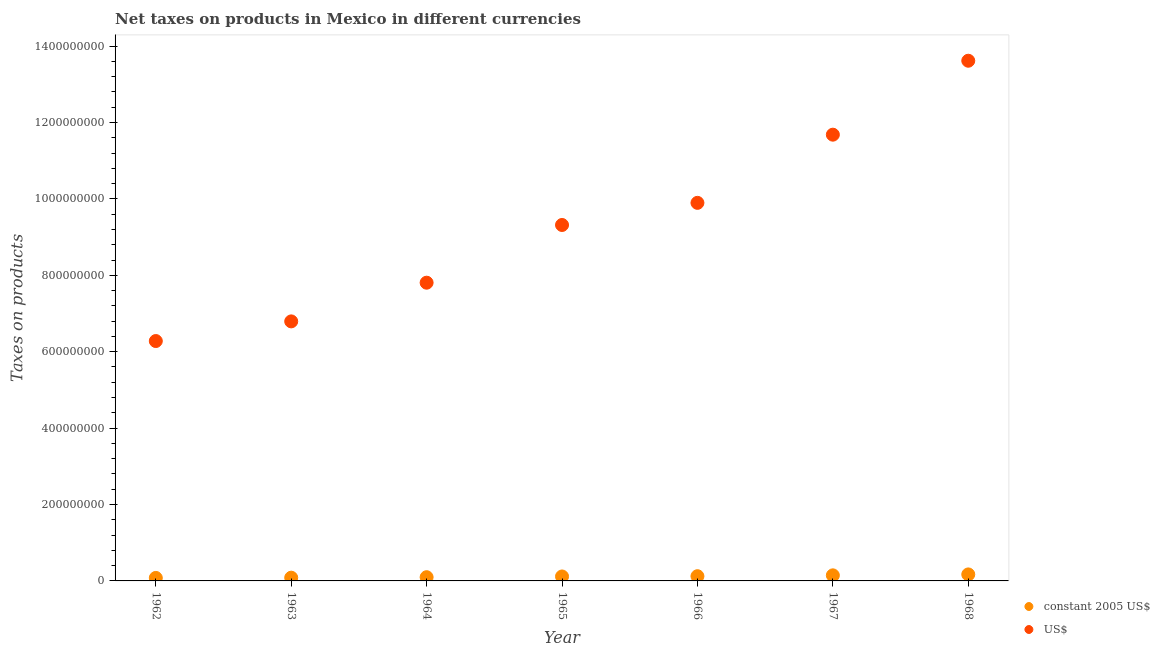Is the number of dotlines equal to the number of legend labels?
Make the answer very short. Yes. What is the net taxes in constant 2005 us$ in 1968?
Your answer should be compact. 1.70e+07. Across all years, what is the maximum net taxes in us$?
Offer a terse response. 1.36e+09. Across all years, what is the minimum net taxes in constant 2005 us$?
Your answer should be compact. 7.85e+06. In which year was the net taxes in constant 2005 us$ maximum?
Make the answer very short. 1968. In which year was the net taxes in us$ minimum?
Your response must be concise. 1962. What is the total net taxes in us$ in the graph?
Your answer should be compact. 6.54e+09. What is the difference between the net taxes in us$ in 1963 and that in 1965?
Ensure brevity in your answer.  -2.52e+08. What is the difference between the net taxes in constant 2005 us$ in 1963 and the net taxes in us$ in 1965?
Your answer should be compact. -9.23e+08. What is the average net taxes in constant 2005 us$ per year?
Provide a succinct answer. 1.17e+07. In the year 1964, what is the difference between the net taxes in constant 2005 us$ and net taxes in us$?
Give a very brief answer. -7.71e+08. In how many years, is the net taxes in constant 2005 us$ greater than 560000000 units?
Offer a very short reply. 0. What is the ratio of the net taxes in constant 2005 us$ in 1963 to that in 1964?
Your answer should be very brief. 0.87. Is the difference between the net taxes in us$ in 1966 and 1968 greater than the difference between the net taxes in constant 2005 us$ in 1966 and 1968?
Your answer should be very brief. No. What is the difference between the highest and the second highest net taxes in us$?
Offer a terse response. 1.94e+08. What is the difference between the highest and the lowest net taxes in constant 2005 us$?
Provide a short and direct response. 9.17e+06. Is the net taxes in us$ strictly less than the net taxes in constant 2005 us$ over the years?
Keep it short and to the point. No. What is the difference between two consecutive major ticks on the Y-axis?
Your answer should be very brief. 2.00e+08. Are the values on the major ticks of Y-axis written in scientific E-notation?
Ensure brevity in your answer.  No. Does the graph contain any zero values?
Your response must be concise. No. Does the graph contain grids?
Provide a short and direct response. No. How many legend labels are there?
Your response must be concise. 2. How are the legend labels stacked?
Your answer should be very brief. Vertical. What is the title of the graph?
Provide a succinct answer. Net taxes on products in Mexico in different currencies. What is the label or title of the X-axis?
Your answer should be very brief. Year. What is the label or title of the Y-axis?
Your response must be concise. Taxes on products. What is the Taxes on products in constant 2005 US$ in 1962?
Your answer should be very brief. 7.85e+06. What is the Taxes on products in US$ in 1962?
Give a very brief answer. 6.28e+08. What is the Taxes on products in constant 2005 US$ in 1963?
Provide a succinct answer. 8.49e+06. What is the Taxes on products of US$ in 1963?
Offer a terse response. 6.79e+08. What is the Taxes on products of constant 2005 US$ in 1964?
Offer a terse response. 9.76e+06. What is the Taxes on products in US$ in 1964?
Offer a terse response. 7.81e+08. What is the Taxes on products of constant 2005 US$ in 1965?
Keep it short and to the point. 1.16e+07. What is the Taxes on products in US$ in 1965?
Ensure brevity in your answer.  9.32e+08. What is the Taxes on products of constant 2005 US$ in 1966?
Make the answer very short. 1.24e+07. What is the Taxes on products in US$ in 1966?
Provide a short and direct response. 9.90e+08. What is the Taxes on products of constant 2005 US$ in 1967?
Your answer should be compact. 1.46e+07. What is the Taxes on products in US$ in 1967?
Keep it short and to the point. 1.17e+09. What is the Taxes on products of constant 2005 US$ in 1968?
Make the answer very short. 1.70e+07. What is the Taxes on products in US$ in 1968?
Your response must be concise. 1.36e+09. Across all years, what is the maximum Taxes on products in constant 2005 US$?
Provide a succinct answer. 1.70e+07. Across all years, what is the maximum Taxes on products in US$?
Give a very brief answer. 1.36e+09. Across all years, what is the minimum Taxes on products in constant 2005 US$?
Offer a very short reply. 7.85e+06. Across all years, what is the minimum Taxes on products of US$?
Your response must be concise. 6.28e+08. What is the total Taxes on products of constant 2005 US$ in the graph?
Make the answer very short. 8.17e+07. What is the total Taxes on products in US$ in the graph?
Your answer should be very brief. 6.54e+09. What is the difference between the Taxes on products in constant 2005 US$ in 1962 and that in 1963?
Provide a succinct answer. -6.43e+05. What is the difference between the Taxes on products in US$ in 1962 and that in 1963?
Provide a succinct answer. -5.14e+07. What is the difference between the Taxes on products in constant 2005 US$ in 1962 and that in 1964?
Your answer should be very brief. -1.91e+06. What is the difference between the Taxes on products in US$ in 1962 and that in 1964?
Your answer should be very brief. -1.53e+08. What is the difference between the Taxes on products in constant 2005 US$ in 1962 and that in 1965?
Give a very brief answer. -3.80e+06. What is the difference between the Taxes on products in US$ in 1962 and that in 1965?
Offer a very short reply. -3.04e+08. What is the difference between the Taxes on products in constant 2005 US$ in 1962 and that in 1966?
Your answer should be very brief. -4.52e+06. What is the difference between the Taxes on products of US$ in 1962 and that in 1966?
Offer a very short reply. -3.62e+08. What is the difference between the Taxes on products in constant 2005 US$ in 1962 and that in 1967?
Offer a terse response. -6.75e+06. What is the difference between the Taxes on products of US$ in 1962 and that in 1967?
Ensure brevity in your answer.  -5.40e+08. What is the difference between the Taxes on products of constant 2005 US$ in 1962 and that in 1968?
Give a very brief answer. -9.17e+06. What is the difference between the Taxes on products of US$ in 1962 and that in 1968?
Provide a short and direct response. -7.34e+08. What is the difference between the Taxes on products of constant 2005 US$ in 1963 and that in 1964?
Give a very brief answer. -1.27e+06. What is the difference between the Taxes on products of US$ in 1963 and that in 1964?
Keep it short and to the point. -1.01e+08. What is the difference between the Taxes on products in constant 2005 US$ in 1963 and that in 1965?
Make the answer very short. -3.15e+06. What is the difference between the Taxes on products of US$ in 1963 and that in 1965?
Provide a short and direct response. -2.52e+08. What is the difference between the Taxes on products in constant 2005 US$ in 1963 and that in 1966?
Your answer should be compact. -3.88e+06. What is the difference between the Taxes on products in US$ in 1963 and that in 1966?
Your answer should be very brief. -3.10e+08. What is the difference between the Taxes on products of constant 2005 US$ in 1963 and that in 1967?
Give a very brief answer. -6.11e+06. What is the difference between the Taxes on products in US$ in 1963 and that in 1967?
Offer a very short reply. -4.89e+08. What is the difference between the Taxes on products of constant 2005 US$ in 1963 and that in 1968?
Your answer should be compact. -8.53e+06. What is the difference between the Taxes on products of US$ in 1963 and that in 1968?
Keep it short and to the point. -6.82e+08. What is the difference between the Taxes on products in constant 2005 US$ in 1964 and that in 1965?
Keep it short and to the point. -1.89e+06. What is the difference between the Taxes on products in US$ in 1964 and that in 1965?
Your answer should be compact. -1.51e+08. What is the difference between the Taxes on products in constant 2005 US$ in 1964 and that in 1966?
Make the answer very short. -2.61e+06. What is the difference between the Taxes on products in US$ in 1964 and that in 1966?
Your response must be concise. -2.09e+08. What is the difference between the Taxes on products in constant 2005 US$ in 1964 and that in 1967?
Ensure brevity in your answer.  -4.84e+06. What is the difference between the Taxes on products of US$ in 1964 and that in 1967?
Your answer should be compact. -3.87e+08. What is the difference between the Taxes on products of constant 2005 US$ in 1964 and that in 1968?
Make the answer very short. -7.26e+06. What is the difference between the Taxes on products in US$ in 1964 and that in 1968?
Keep it short and to the point. -5.81e+08. What is the difference between the Taxes on products in constant 2005 US$ in 1965 and that in 1966?
Ensure brevity in your answer.  -7.24e+05. What is the difference between the Taxes on products of US$ in 1965 and that in 1966?
Your answer should be very brief. -5.79e+07. What is the difference between the Taxes on products of constant 2005 US$ in 1965 and that in 1967?
Your response must be concise. -2.96e+06. What is the difference between the Taxes on products of US$ in 1965 and that in 1967?
Give a very brief answer. -2.36e+08. What is the difference between the Taxes on products of constant 2005 US$ in 1965 and that in 1968?
Provide a short and direct response. -5.37e+06. What is the difference between the Taxes on products of US$ in 1965 and that in 1968?
Offer a very short reply. -4.30e+08. What is the difference between the Taxes on products of constant 2005 US$ in 1966 and that in 1967?
Provide a succinct answer. -2.23e+06. What is the difference between the Taxes on products in US$ in 1966 and that in 1967?
Your answer should be compact. -1.78e+08. What is the difference between the Taxes on products in constant 2005 US$ in 1966 and that in 1968?
Give a very brief answer. -4.65e+06. What is the difference between the Taxes on products of US$ in 1966 and that in 1968?
Provide a short and direct response. -3.72e+08. What is the difference between the Taxes on products of constant 2005 US$ in 1967 and that in 1968?
Your response must be concise. -2.42e+06. What is the difference between the Taxes on products of US$ in 1967 and that in 1968?
Your answer should be very brief. -1.94e+08. What is the difference between the Taxes on products in constant 2005 US$ in 1962 and the Taxes on products in US$ in 1963?
Your answer should be very brief. -6.72e+08. What is the difference between the Taxes on products in constant 2005 US$ in 1962 and the Taxes on products in US$ in 1964?
Your answer should be compact. -7.73e+08. What is the difference between the Taxes on products in constant 2005 US$ in 1962 and the Taxes on products in US$ in 1965?
Provide a short and direct response. -9.24e+08. What is the difference between the Taxes on products in constant 2005 US$ in 1962 and the Taxes on products in US$ in 1966?
Keep it short and to the point. -9.82e+08. What is the difference between the Taxes on products of constant 2005 US$ in 1962 and the Taxes on products of US$ in 1967?
Give a very brief answer. -1.16e+09. What is the difference between the Taxes on products of constant 2005 US$ in 1962 and the Taxes on products of US$ in 1968?
Make the answer very short. -1.35e+09. What is the difference between the Taxes on products in constant 2005 US$ in 1963 and the Taxes on products in US$ in 1964?
Provide a succinct answer. -7.72e+08. What is the difference between the Taxes on products of constant 2005 US$ in 1963 and the Taxes on products of US$ in 1965?
Offer a terse response. -9.23e+08. What is the difference between the Taxes on products in constant 2005 US$ in 1963 and the Taxes on products in US$ in 1966?
Give a very brief answer. -9.81e+08. What is the difference between the Taxes on products of constant 2005 US$ in 1963 and the Taxes on products of US$ in 1967?
Make the answer very short. -1.16e+09. What is the difference between the Taxes on products of constant 2005 US$ in 1963 and the Taxes on products of US$ in 1968?
Your answer should be compact. -1.35e+09. What is the difference between the Taxes on products of constant 2005 US$ in 1964 and the Taxes on products of US$ in 1965?
Keep it short and to the point. -9.22e+08. What is the difference between the Taxes on products in constant 2005 US$ in 1964 and the Taxes on products in US$ in 1966?
Give a very brief answer. -9.80e+08. What is the difference between the Taxes on products in constant 2005 US$ in 1964 and the Taxes on products in US$ in 1967?
Your answer should be compact. -1.16e+09. What is the difference between the Taxes on products of constant 2005 US$ in 1964 and the Taxes on products of US$ in 1968?
Your response must be concise. -1.35e+09. What is the difference between the Taxes on products in constant 2005 US$ in 1965 and the Taxes on products in US$ in 1966?
Make the answer very short. -9.78e+08. What is the difference between the Taxes on products of constant 2005 US$ in 1965 and the Taxes on products of US$ in 1967?
Provide a succinct answer. -1.16e+09. What is the difference between the Taxes on products in constant 2005 US$ in 1965 and the Taxes on products in US$ in 1968?
Offer a terse response. -1.35e+09. What is the difference between the Taxes on products of constant 2005 US$ in 1966 and the Taxes on products of US$ in 1967?
Your response must be concise. -1.16e+09. What is the difference between the Taxes on products in constant 2005 US$ in 1966 and the Taxes on products in US$ in 1968?
Provide a short and direct response. -1.35e+09. What is the difference between the Taxes on products of constant 2005 US$ in 1967 and the Taxes on products of US$ in 1968?
Offer a terse response. -1.35e+09. What is the average Taxes on products of constant 2005 US$ per year?
Provide a short and direct response. 1.17e+07. What is the average Taxes on products in US$ per year?
Ensure brevity in your answer.  9.34e+08. In the year 1962, what is the difference between the Taxes on products in constant 2005 US$ and Taxes on products in US$?
Offer a very short reply. -6.20e+08. In the year 1963, what is the difference between the Taxes on products of constant 2005 US$ and Taxes on products of US$?
Provide a succinct answer. -6.71e+08. In the year 1964, what is the difference between the Taxes on products in constant 2005 US$ and Taxes on products in US$?
Offer a terse response. -7.71e+08. In the year 1965, what is the difference between the Taxes on products of constant 2005 US$ and Taxes on products of US$?
Offer a terse response. -9.20e+08. In the year 1966, what is the difference between the Taxes on products in constant 2005 US$ and Taxes on products in US$?
Your answer should be compact. -9.77e+08. In the year 1967, what is the difference between the Taxes on products of constant 2005 US$ and Taxes on products of US$?
Your answer should be very brief. -1.15e+09. In the year 1968, what is the difference between the Taxes on products in constant 2005 US$ and Taxes on products in US$?
Provide a succinct answer. -1.34e+09. What is the ratio of the Taxes on products of constant 2005 US$ in 1962 to that in 1963?
Give a very brief answer. 0.92. What is the ratio of the Taxes on products in US$ in 1962 to that in 1963?
Make the answer very short. 0.92. What is the ratio of the Taxes on products in constant 2005 US$ in 1962 to that in 1964?
Provide a succinct answer. 0.8. What is the ratio of the Taxes on products in US$ in 1962 to that in 1964?
Provide a short and direct response. 0.8. What is the ratio of the Taxes on products of constant 2005 US$ in 1962 to that in 1965?
Your answer should be very brief. 0.67. What is the ratio of the Taxes on products of US$ in 1962 to that in 1965?
Your answer should be very brief. 0.67. What is the ratio of the Taxes on products in constant 2005 US$ in 1962 to that in 1966?
Offer a terse response. 0.63. What is the ratio of the Taxes on products of US$ in 1962 to that in 1966?
Offer a terse response. 0.63. What is the ratio of the Taxes on products in constant 2005 US$ in 1962 to that in 1967?
Provide a short and direct response. 0.54. What is the ratio of the Taxes on products of US$ in 1962 to that in 1967?
Provide a short and direct response. 0.54. What is the ratio of the Taxes on products in constant 2005 US$ in 1962 to that in 1968?
Keep it short and to the point. 0.46. What is the ratio of the Taxes on products of US$ in 1962 to that in 1968?
Offer a terse response. 0.46. What is the ratio of the Taxes on products in constant 2005 US$ in 1963 to that in 1964?
Your response must be concise. 0.87. What is the ratio of the Taxes on products in US$ in 1963 to that in 1964?
Provide a short and direct response. 0.87. What is the ratio of the Taxes on products of constant 2005 US$ in 1963 to that in 1965?
Ensure brevity in your answer.  0.73. What is the ratio of the Taxes on products in US$ in 1963 to that in 1965?
Offer a very short reply. 0.73. What is the ratio of the Taxes on products in constant 2005 US$ in 1963 to that in 1966?
Your response must be concise. 0.69. What is the ratio of the Taxes on products of US$ in 1963 to that in 1966?
Give a very brief answer. 0.69. What is the ratio of the Taxes on products of constant 2005 US$ in 1963 to that in 1967?
Your answer should be compact. 0.58. What is the ratio of the Taxes on products of US$ in 1963 to that in 1967?
Offer a terse response. 0.58. What is the ratio of the Taxes on products of constant 2005 US$ in 1963 to that in 1968?
Offer a very short reply. 0.5. What is the ratio of the Taxes on products of US$ in 1963 to that in 1968?
Offer a terse response. 0.5. What is the ratio of the Taxes on products of constant 2005 US$ in 1964 to that in 1965?
Your answer should be very brief. 0.84. What is the ratio of the Taxes on products of US$ in 1964 to that in 1965?
Your answer should be compact. 0.84. What is the ratio of the Taxes on products in constant 2005 US$ in 1964 to that in 1966?
Your answer should be very brief. 0.79. What is the ratio of the Taxes on products in US$ in 1964 to that in 1966?
Give a very brief answer. 0.79. What is the ratio of the Taxes on products in constant 2005 US$ in 1964 to that in 1967?
Provide a short and direct response. 0.67. What is the ratio of the Taxes on products in US$ in 1964 to that in 1967?
Make the answer very short. 0.67. What is the ratio of the Taxes on products in constant 2005 US$ in 1964 to that in 1968?
Provide a short and direct response. 0.57. What is the ratio of the Taxes on products in US$ in 1964 to that in 1968?
Provide a short and direct response. 0.57. What is the ratio of the Taxes on products of constant 2005 US$ in 1965 to that in 1966?
Make the answer very short. 0.94. What is the ratio of the Taxes on products in US$ in 1965 to that in 1966?
Provide a succinct answer. 0.94. What is the ratio of the Taxes on products of constant 2005 US$ in 1965 to that in 1967?
Give a very brief answer. 0.8. What is the ratio of the Taxes on products of US$ in 1965 to that in 1967?
Your response must be concise. 0.8. What is the ratio of the Taxes on products in constant 2005 US$ in 1965 to that in 1968?
Provide a succinct answer. 0.68. What is the ratio of the Taxes on products of US$ in 1965 to that in 1968?
Your response must be concise. 0.68. What is the ratio of the Taxes on products in constant 2005 US$ in 1966 to that in 1967?
Keep it short and to the point. 0.85. What is the ratio of the Taxes on products of US$ in 1966 to that in 1967?
Your response must be concise. 0.85. What is the ratio of the Taxes on products of constant 2005 US$ in 1966 to that in 1968?
Offer a very short reply. 0.73. What is the ratio of the Taxes on products of US$ in 1966 to that in 1968?
Provide a succinct answer. 0.73. What is the ratio of the Taxes on products of constant 2005 US$ in 1967 to that in 1968?
Make the answer very short. 0.86. What is the ratio of the Taxes on products of US$ in 1967 to that in 1968?
Provide a short and direct response. 0.86. What is the difference between the highest and the second highest Taxes on products in constant 2005 US$?
Give a very brief answer. 2.42e+06. What is the difference between the highest and the second highest Taxes on products of US$?
Your answer should be compact. 1.94e+08. What is the difference between the highest and the lowest Taxes on products of constant 2005 US$?
Provide a succinct answer. 9.17e+06. What is the difference between the highest and the lowest Taxes on products in US$?
Your response must be concise. 7.34e+08. 